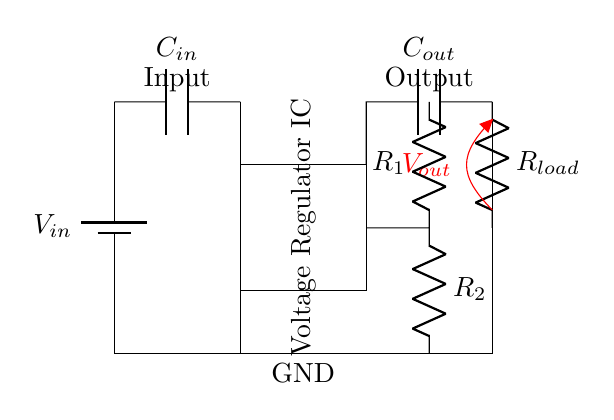What is the function of the voltage regulator IC? The voltage regulator IC is responsible for maintaining a stable output voltage despite variations in input voltage or load conditions. It ensures that the connected load receives a consistent voltage, which is critical for the performance of portable electronics.
Answer: maintaining stable voltage What are the values marked for the capacitors? The circuit shows two capacitors labeled as C in and C out, which likely serve to filter the input and output voltage, respectively. C in is connected at the input, and C out is placed at the output, stabilizing the voltage supplied to the load by smoothing fluctuations.
Answer: C in and C out What role does the load resistor play in this circuit? The load resistor, R load, represents the component that consumes power from the regulated output voltage. It provides a path for the current flowing away from the output of the voltage regulator, allowing the circuit to function as intended.
Answer: consumes power Which component connects the voltage regulator to the ground? The voltage regulator IC is connected to the ground through a direct line from one of its pins. This connection is crucial for completing the circuit and establishing a reference point for the output voltage. Additionally, the ground connection stabilizes the entire circuit's operation.
Answer: ground connection How do R 1 and R 2 affect the output voltage? The resistors R 1 and R 2 are part of a voltage divider network, which determines the output voltage by setting the ratio of their values. The output voltage is influenced by the proportion of resistance in R 1 compared to R 2, thus adjusting the voltage level supplied to the load.
Answer: sets output voltage 